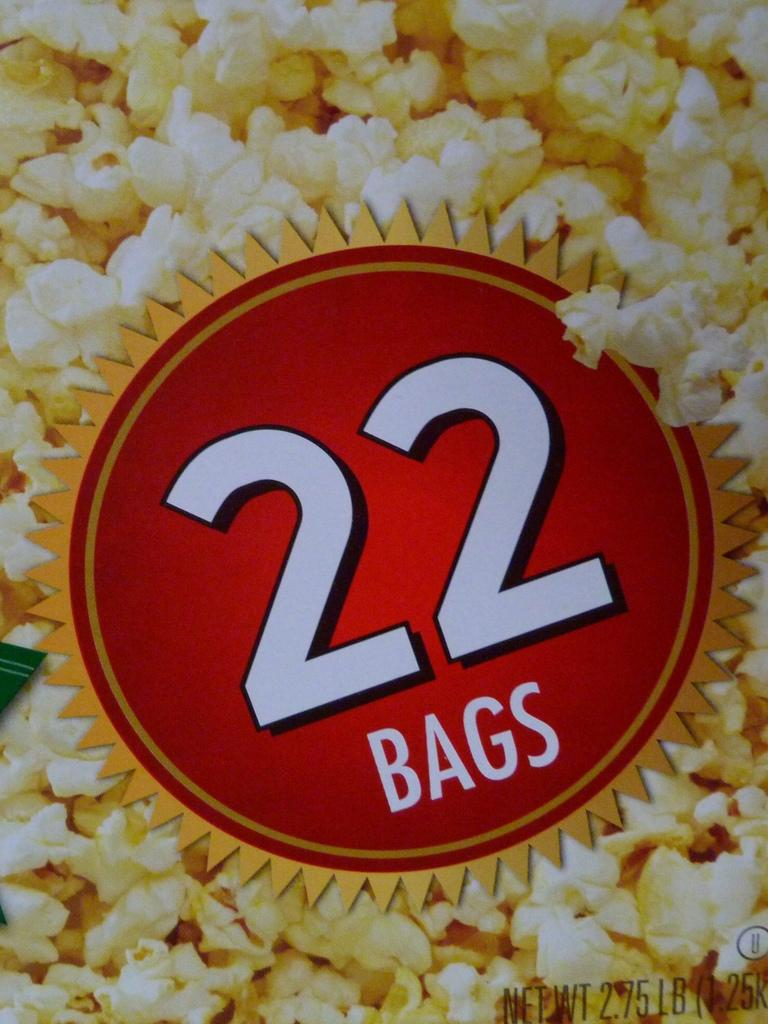What type of content is the image promoting? The image is an advertisement. What product or service might the advertisement be promoting? The presence of popcorns in the image suggests that it could be promoting a movie theater, snack, or related product. What can be found in the image besides the popcorns? There is text and a logo in the image. What type of silk fabric is being used to make the women's dresses in the image? There are no women or dresses present in the image, and therefore no silk fabric can be observed. 